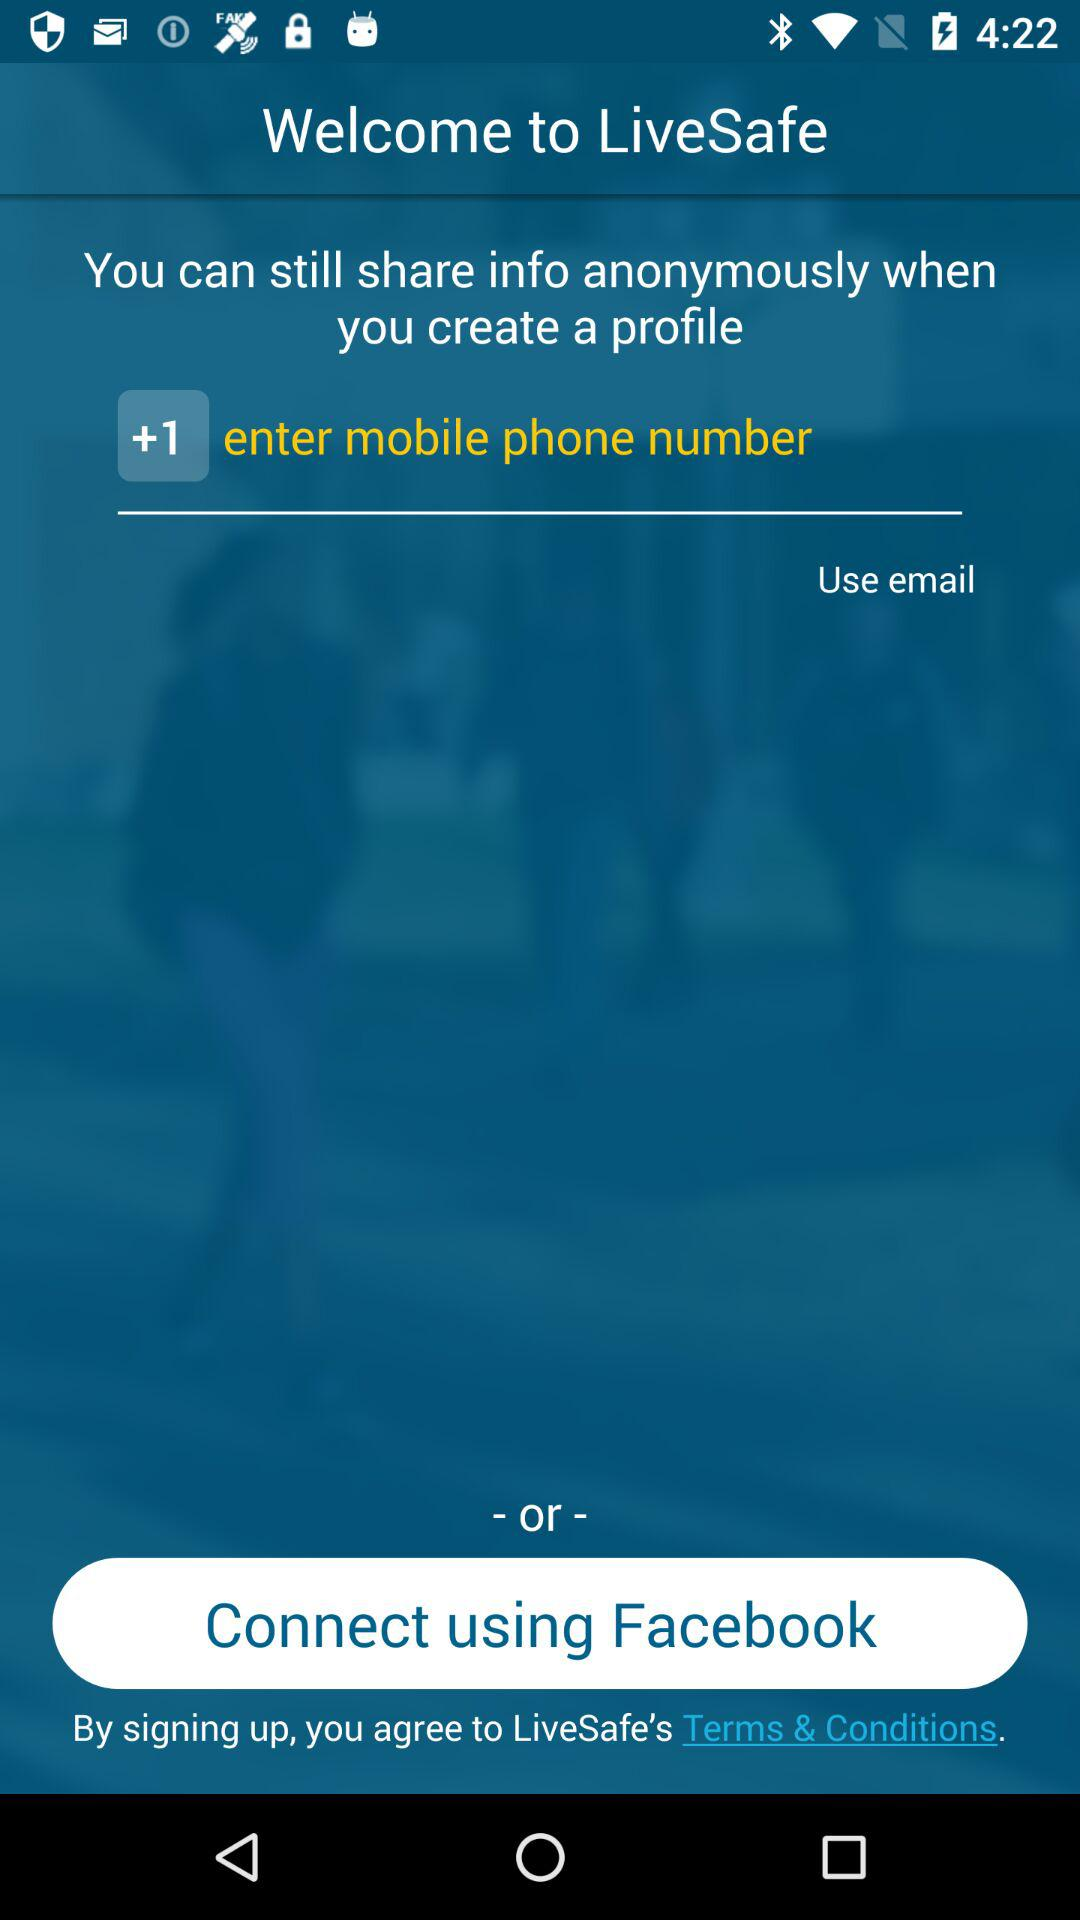How can we connect? You can connect using your "mobile phone number", "email" and "Facebook". 